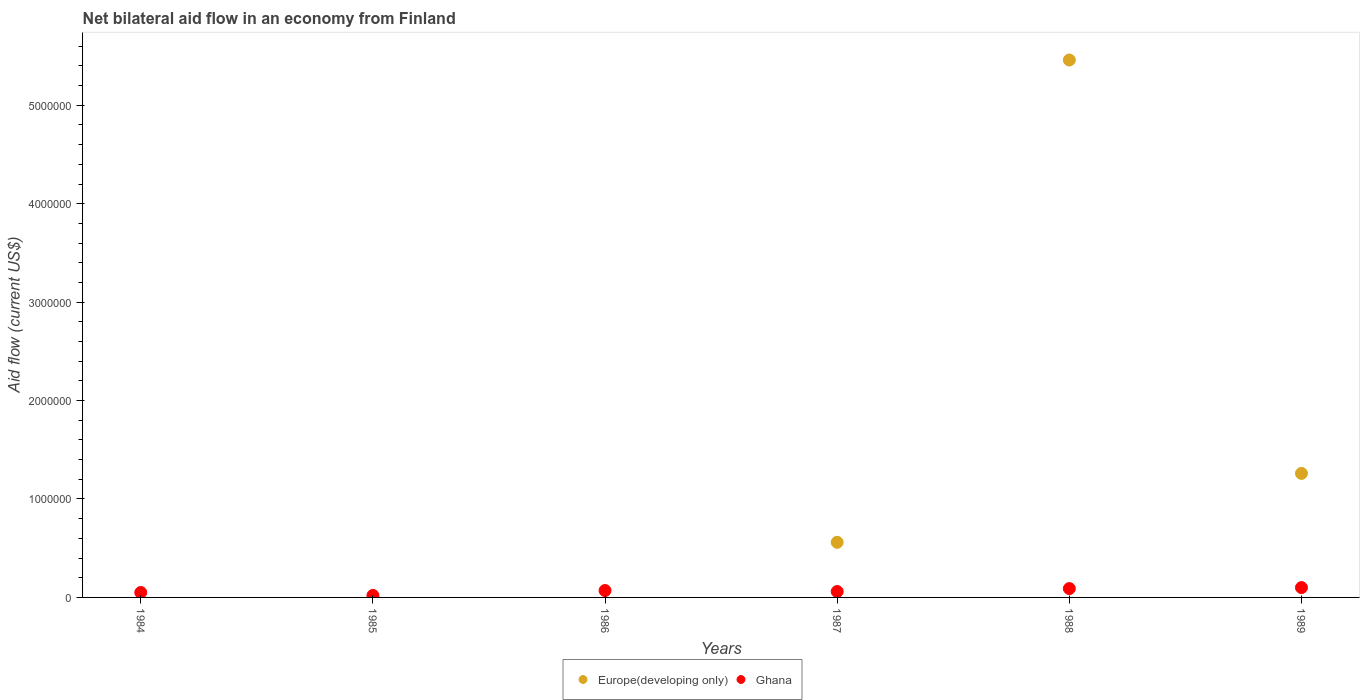How many different coloured dotlines are there?
Keep it short and to the point. 2. Is the number of dotlines equal to the number of legend labels?
Offer a terse response. No. In which year was the net bilateral aid flow in Europe(developing only) maximum?
Provide a short and direct response. 1988. What is the total net bilateral aid flow in Europe(developing only) in the graph?
Make the answer very short. 7.28e+06. What is the difference between the net bilateral aid flow in Europe(developing only) in 1989 and the net bilateral aid flow in Ghana in 1987?
Offer a very short reply. 1.20e+06. What is the average net bilateral aid flow in Europe(developing only) per year?
Ensure brevity in your answer.  1.21e+06. In the year 1988, what is the difference between the net bilateral aid flow in Ghana and net bilateral aid flow in Europe(developing only)?
Offer a terse response. -5.37e+06. In how many years, is the net bilateral aid flow in Europe(developing only) greater than 200000 US$?
Your answer should be compact. 3. What is the ratio of the net bilateral aid flow in Ghana in 1984 to that in 1987?
Provide a succinct answer. 0.83. Is the difference between the net bilateral aid flow in Ghana in 1988 and 1989 greater than the difference between the net bilateral aid flow in Europe(developing only) in 1988 and 1989?
Offer a terse response. No. What is the difference between the highest and the lowest net bilateral aid flow in Europe(developing only)?
Keep it short and to the point. 5.46e+06. In how many years, is the net bilateral aid flow in Ghana greater than the average net bilateral aid flow in Ghana taken over all years?
Make the answer very short. 3. Does the net bilateral aid flow in Ghana monotonically increase over the years?
Provide a succinct answer. No. Is the net bilateral aid flow in Ghana strictly greater than the net bilateral aid flow in Europe(developing only) over the years?
Give a very brief answer. No. How many dotlines are there?
Your answer should be very brief. 2. How many years are there in the graph?
Your response must be concise. 6. Are the values on the major ticks of Y-axis written in scientific E-notation?
Your answer should be compact. No. Does the graph contain grids?
Your answer should be very brief. No. Where does the legend appear in the graph?
Your answer should be very brief. Bottom center. How many legend labels are there?
Provide a short and direct response. 2. How are the legend labels stacked?
Offer a very short reply. Horizontal. What is the title of the graph?
Ensure brevity in your answer.  Net bilateral aid flow in an economy from Finland. Does "France" appear as one of the legend labels in the graph?
Offer a very short reply. No. What is the label or title of the X-axis?
Provide a succinct answer. Years. What is the Aid flow (current US$) of Ghana in 1984?
Your answer should be compact. 5.00e+04. What is the Aid flow (current US$) of Europe(developing only) in 1985?
Make the answer very short. 0. What is the Aid flow (current US$) of Ghana in 1985?
Provide a succinct answer. 2.00e+04. What is the Aid flow (current US$) in Europe(developing only) in 1987?
Provide a succinct answer. 5.60e+05. What is the Aid flow (current US$) of Ghana in 1987?
Ensure brevity in your answer.  6.00e+04. What is the Aid flow (current US$) of Europe(developing only) in 1988?
Offer a terse response. 5.46e+06. What is the Aid flow (current US$) of Ghana in 1988?
Ensure brevity in your answer.  9.00e+04. What is the Aid flow (current US$) of Europe(developing only) in 1989?
Keep it short and to the point. 1.26e+06. What is the Aid flow (current US$) in Ghana in 1989?
Your answer should be compact. 1.00e+05. Across all years, what is the maximum Aid flow (current US$) in Europe(developing only)?
Give a very brief answer. 5.46e+06. Across all years, what is the maximum Aid flow (current US$) in Ghana?
Your answer should be compact. 1.00e+05. What is the total Aid flow (current US$) in Europe(developing only) in the graph?
Offer a terse response. 7.28e+06. What is the difference between the Aid flow (current US$) in Ghana in 1984 and that in 1986?
Offer a terse response. -2.00e+04. What is the difference between the Aid flow (current US$) of Ghana in 1984 and that in 1987?
Offer a very short reply. -10000. What is the difference between the Aid flow (current US$) in Ghana in 1984 and that in 1988?
Your answer should be very brief. -4.00e+04. What is the difference between the Aid flow (current US$) of Ghana in 1984 and that in 1989?
Give a very brief answer. -5.00e+04. What is the difference between the Aid flow (current US$) of Ghana in 1986 and that in 1989?
Keep it short and to the point. -3.00e+04. What is the difference between the Aid flow (current US$) of Europe(developing only) in 1987 and that in 1988?
Your answer should be very brief. -4.90e+06. What is the difference between the Aid flow (current US$) in Europe(developing only) in 1987 and that in 1989?
Keep it short and to the point. -7.00e+05. What is the difference between the Aid flow (current US$) in Europe(developing only) in 1988 and that in 1989?
Offer a terse response. 4.20e+06. What is the difference between the Aid flow (current US$) of Europe(developing only) in 1987 and the Aid flow (current US$) of Ghana in 1988?
Give a very brief answer. 4.70e+05. What is the difference between the Aid flow (current US$) of Europe(developing only) in 1988 and the Aid flow (current US$) of Ghana in 1989?
Provide a short and direct response. 5.36e+06. What is the average Aid flow (current US$) in Europe(developing only) per year?
Ensure brevity in your answer.  1.21e+06. What is the average Aid flow (current US$) of Ghana per year?
Your response must be concise. 6.50e+04. In the year 1987, what is the difference between the Aid flow (current US$) of Europe(developing only) and Aid flow (current US$) of Ghana?
Offer a very short reply. 5.00e+05. In the year 1988, what is the difference between the Aid flow (current US$) of Europe(developing only) and Aid flow (current US$) of Ghana?
Provide a short and direct response. 5.37e+06. In the year 1989, what is the difference between the Aid flow (current US$) in Europe(developing only) and Aid flow (current US$) in Ghana?
Your answer should be very brief. 1.16e+06. What is the ratio of the Aid flow (current US$) in Ghana in 1984 to that in 1987?
Keep it short and to the point. 0.83. What is the ratio of the Aid flow (current US$) in Ghana in 1984 to that in 1988?
Offer a very short reply. 0.56. What is the ratio of the Aid flow (current US$) of Ghana in 1985 to that in 1986?
Provide a succinct answer. 0.29. What is the ratio of the Aid flow (current US$) in Ghana in 1985 to that in 1987?
Give a very brief answer. 0.33. What is the ratio of the Aid flow (current US$) in Ghana in 1985 to that in 1988?
Give a very brief answer. 0.22. What is the ratio of the Aid flow (current US$) of Ghana in 1985 to that in 1989?
Provide a succinct answer. 0.2. What is the ratio of the Aid flow (current US$) in Europe(developing only) in 1987 to that in 1988?
Provide a succinct answer. 0.1. What is the ratio of the Aid flow (current US$) of Ghana in 1987 to that in 1988?
Offer a very short reply. 0.67. What is the ratio of the Aid flow (current US$) of Europe(developing only) in 1987 to that in 1989?
Keep it short and to the point. 0.44. What is the ratio of the Aid flow (current US$) in Europe(developing only) in 1988 to that in 1989?
Make the answer very short. 4.33. What is the difference between the highest and the second highest Aid flow (current US$) in Europe(developing only)?
Provide a succinct answer. 4.20e+06. What is the difference between the highest and the lowest Aid flow (current US$) of Europe(developing only)?
Give a very brief answer. 5.46e+06. 